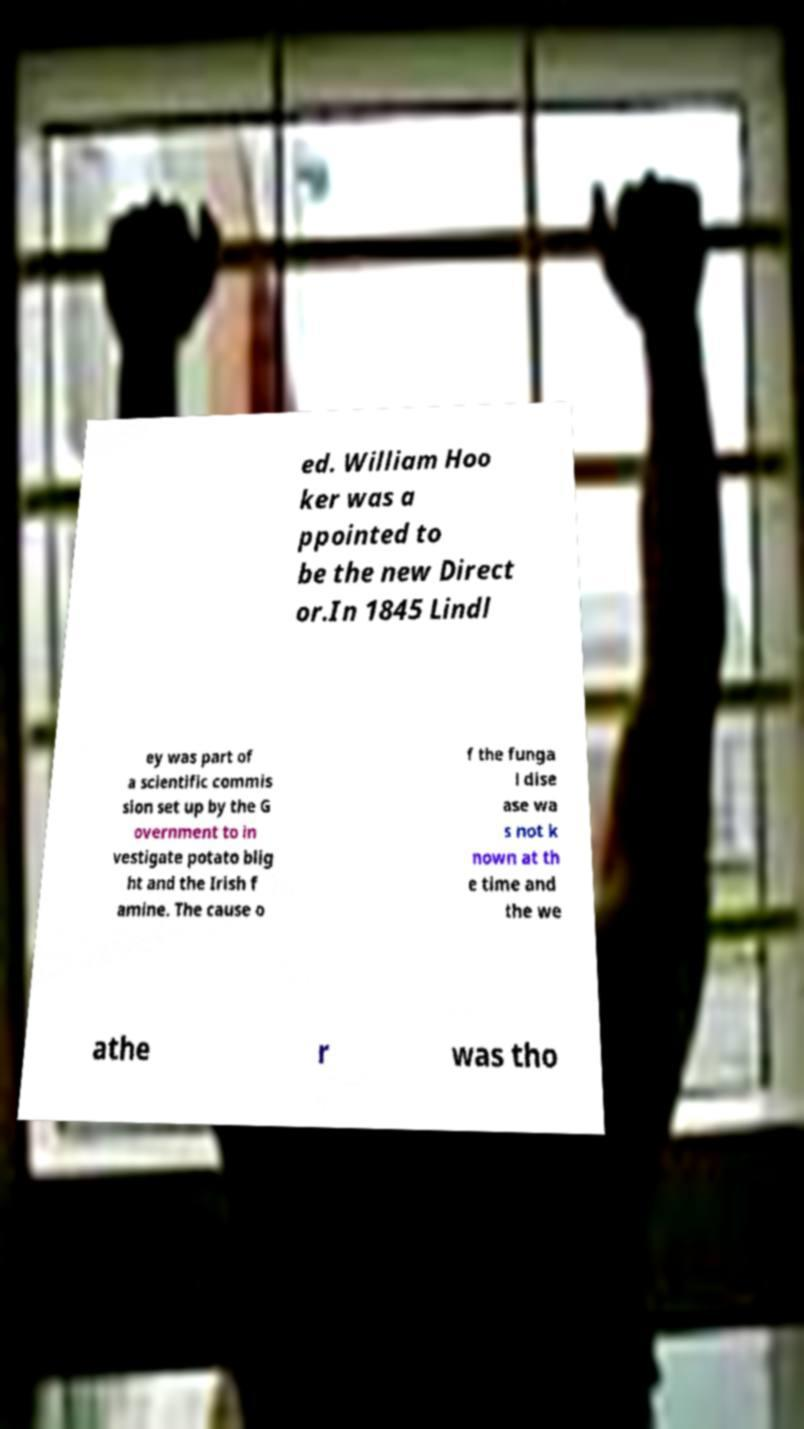What messages or text are displayed in this image? I need them in a readable, typed format. ed. William Hoo ker was a ppointed to be the new Direct or.In 1845 Lindl ey was part of a scientific commis sion set up by the G overnment to in vestigate potato blig ht and the Irish f amine. The cause o f the funga l dise ase wa s not k nown at th e time and the we athe r was tho 